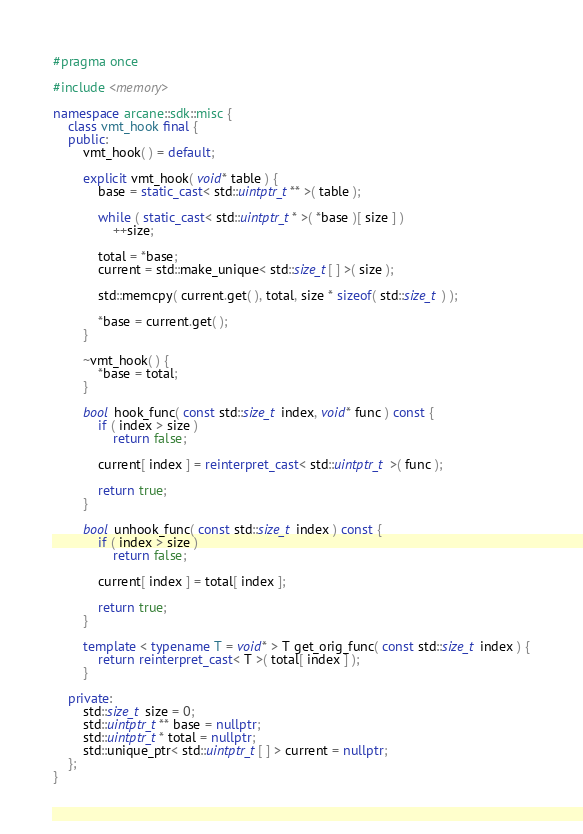Convert code to text. <code><loc_0><loc_0><loc_500><loc_500><_C++_>#pragma once

#include <memory>

namespace arcane::sdk::misc {
	class vmt_hook final {
	public:
		vmt_hook( ) = default;

		explicit vmt_hook( void* table ) {
			base = static_cast< std::uintptr_t** >( table );

			while ( static_cast< std::uintptr_t* >( *base )[ size ] )
				++size;

			total = *base;
			current = std::make_unique< std::size_t[ ] >( size );

			std::memcpy( current.get( ), total, size * sizeof( std::size_t ) );

			*base = current.get( );
		}

		~vmt_hook( ) {
			*base = total;
		}

		bool hook_func( const std::size_t index, void* func ) const {
			if ( index > size )
				return false;

			current[ index ] = reinterpret_cast< std::uintptr_t >( func );

			return true;
		}

		bool unhook_func( const std::size_t index ) const {
			if ( index > size )
				return false;

			current[ index ] = total[ index ];

			return true;
		}

		template < typename T = void* > T get_orig_func( const std::size_t index ) {
			return reinterpret_cast< T >( total[ index ] );
		}

	private:
		std::size_t size = 0;
		std::uintptr_t** base = nullptr;
		std::uintptr_t* total = nullptr;
		std::unique_ptr< std::uintptr_t[ ] > current = nullptr;
	};
}
</code> 